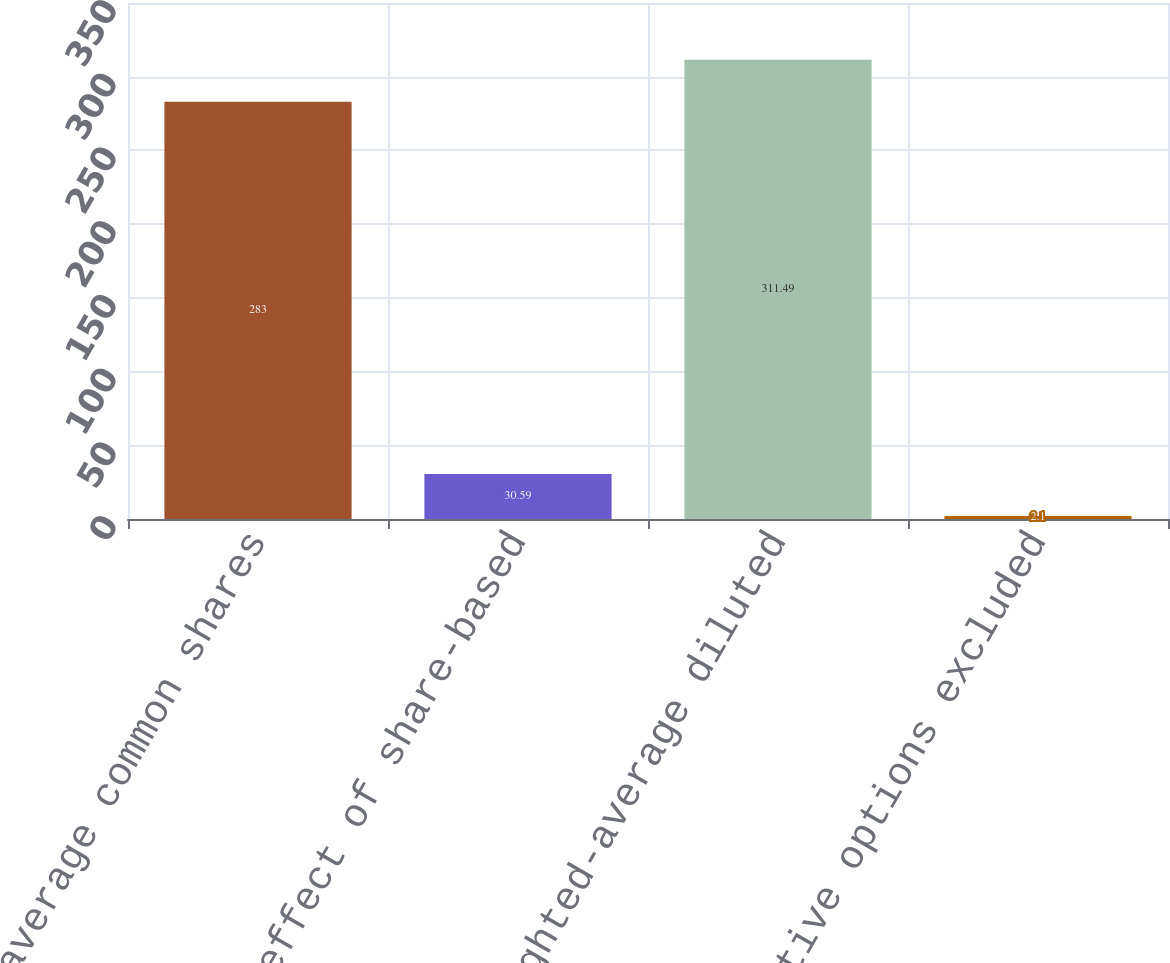Convert chart. <chart><loc_0><loc_0><loc_500><loc_500><bar_chart><fcel>Weighted-average common shares<fcel>Dilutive effect of share-based<fcel>Weighted-average diluted<fcel>Anti-dilutive options excluded<nl><fcel>283<fcel>30.59<fcel>311.49<fcel>2.1<nl></chart> 